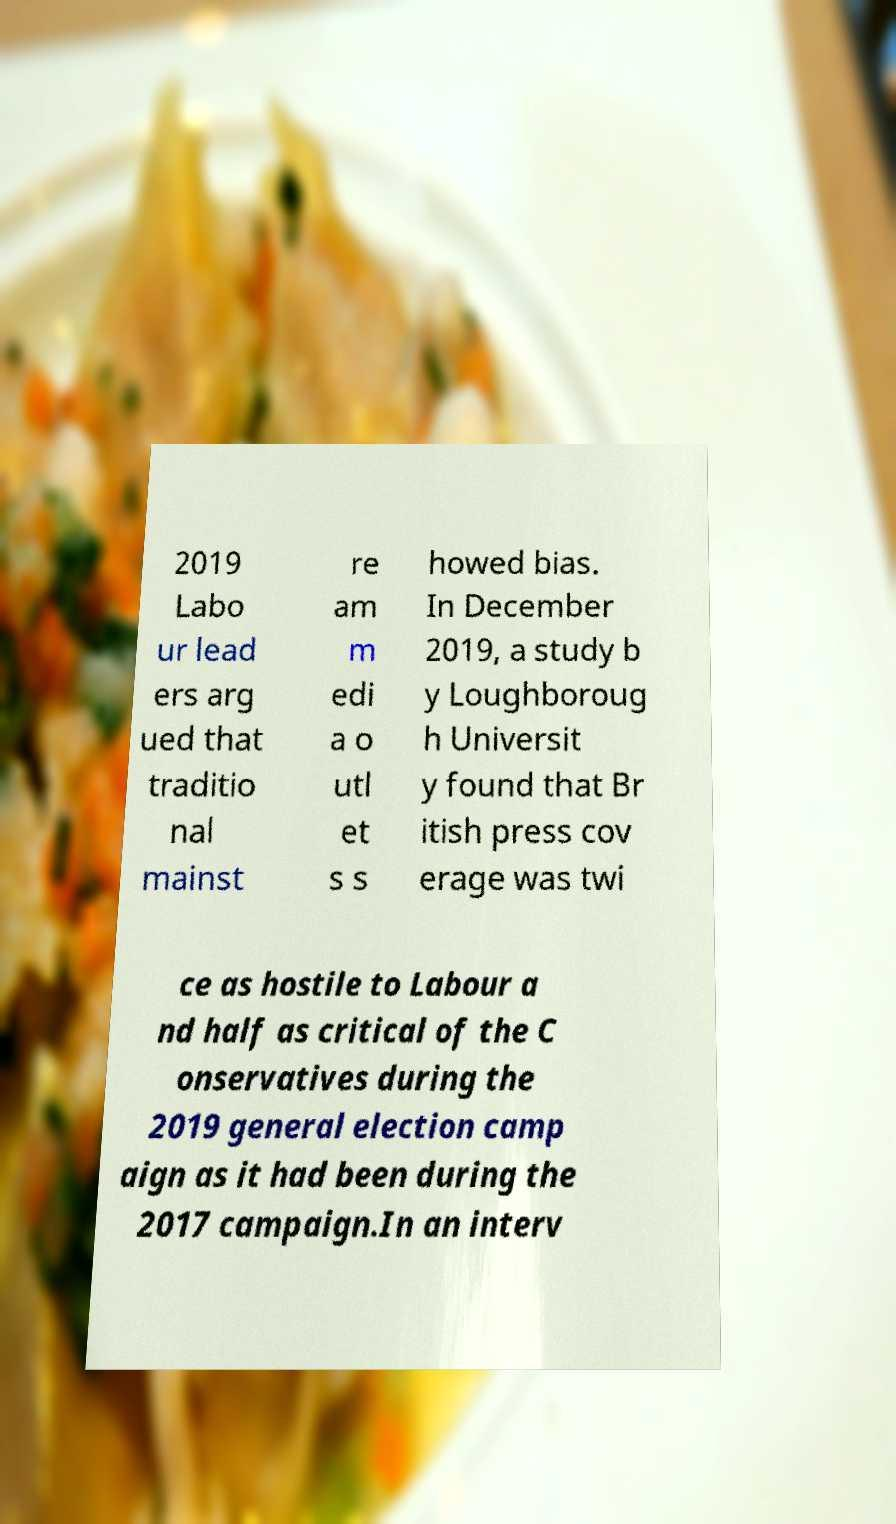Could you assist in decoding the text presented in this image and type it out clearly? 2019 Labo ur lead ers arg ued that traditio nal mainst re am m edi a o utl et s s howed bias. In December 2019, a study b y Loughboroug h Universit y found that Br itish press cov erage was twi ce as hostile to Labour a nd half as critical of the C onservatives during the 2019 general election camp aign as it had been during the 2017 campaign.In an interv 